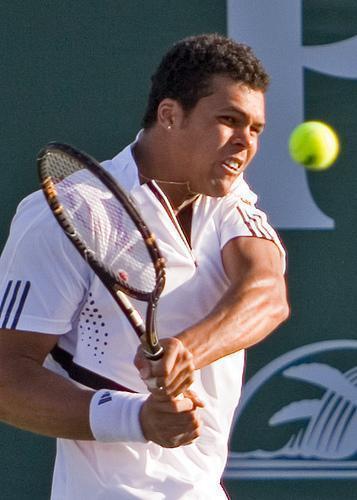This playing is making what shot?
Indicate the correct response by choosing from the four available options to answer the question.
Options: Forehand, serve, lob, backhand. Backhand. 